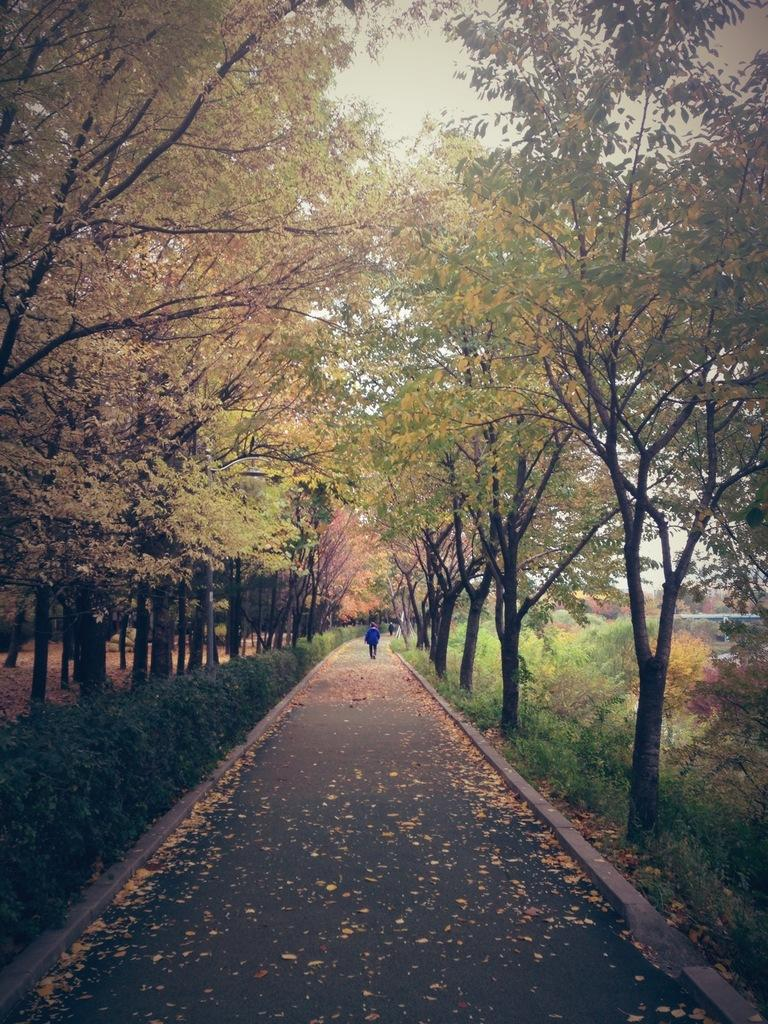What type of vegetation can be seen in the image? There are trees in the image. What kind of path is present in the image? There is a walkway in the image. Are there any living beings in the image? Yes, there are people in the image. What other type of vegetation can be seen besides trees? There are plants in the image. What can be seen in the distance in the image? The sky is visible in the background of the image. Where is the nest located in the image? There is no nest present in the image. What type of blood can be seen on the walkway in the image? There is no blood present in the image. 